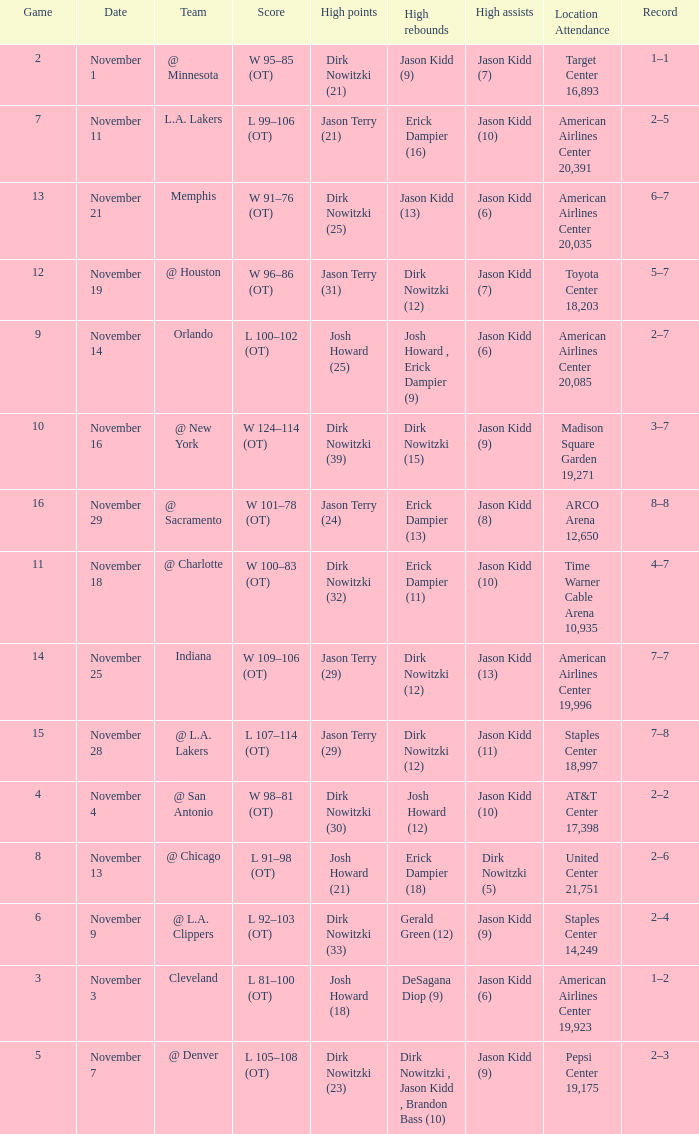What is High Rebounds, when High Assists is "Jason Kidd (13)"? Dirk Nowitzki (12). 